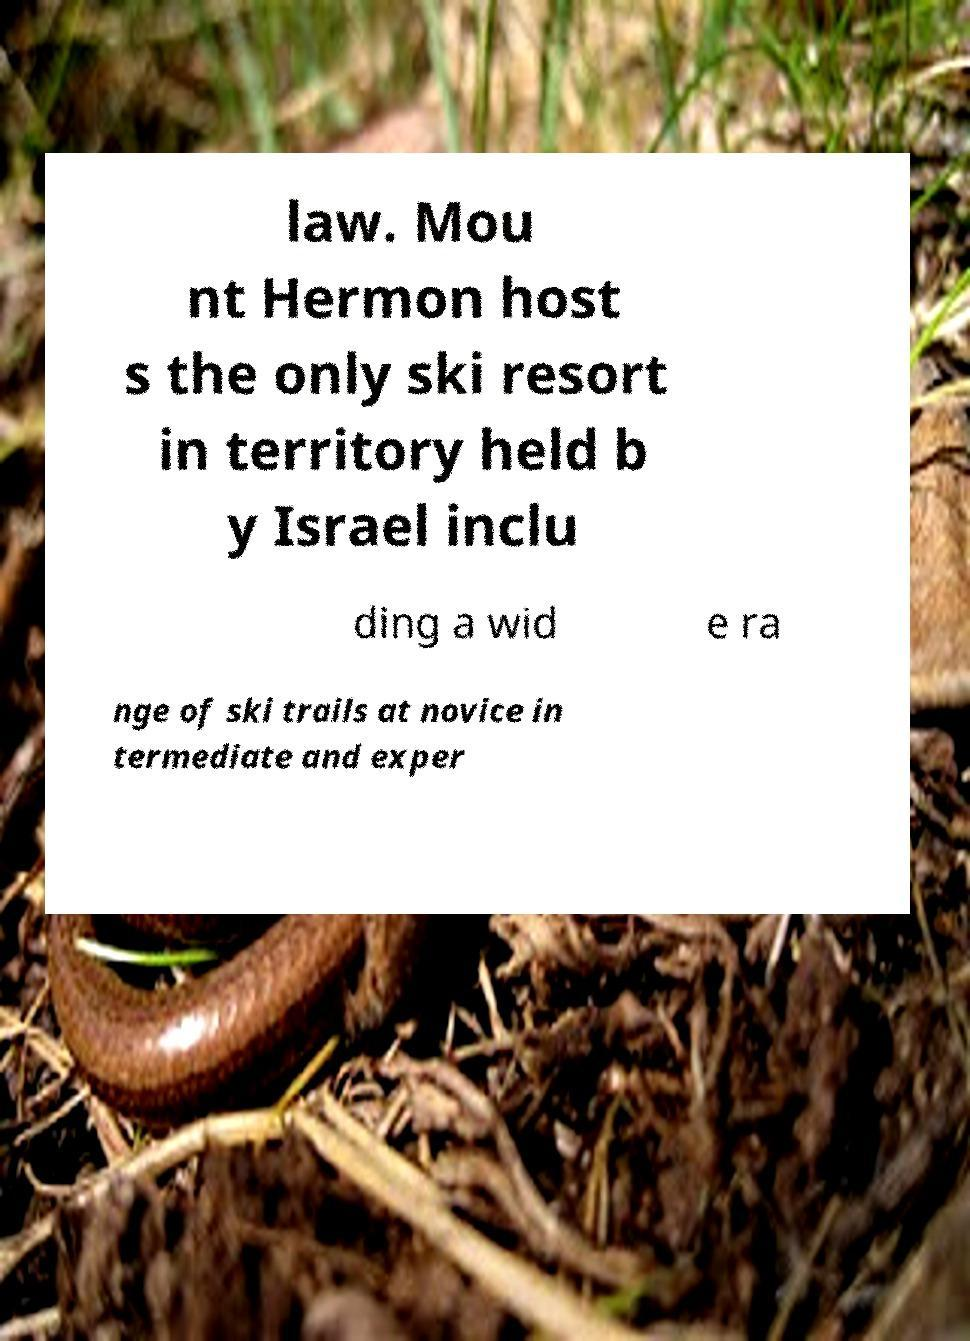Could you assist in decoding the text presented in this image and type it out clearly? law. Mou nt Hermon host s the only ski resort in territory held b y Israel inclu ding a wid e ra nge of ski trails at novice in termediate and exper 